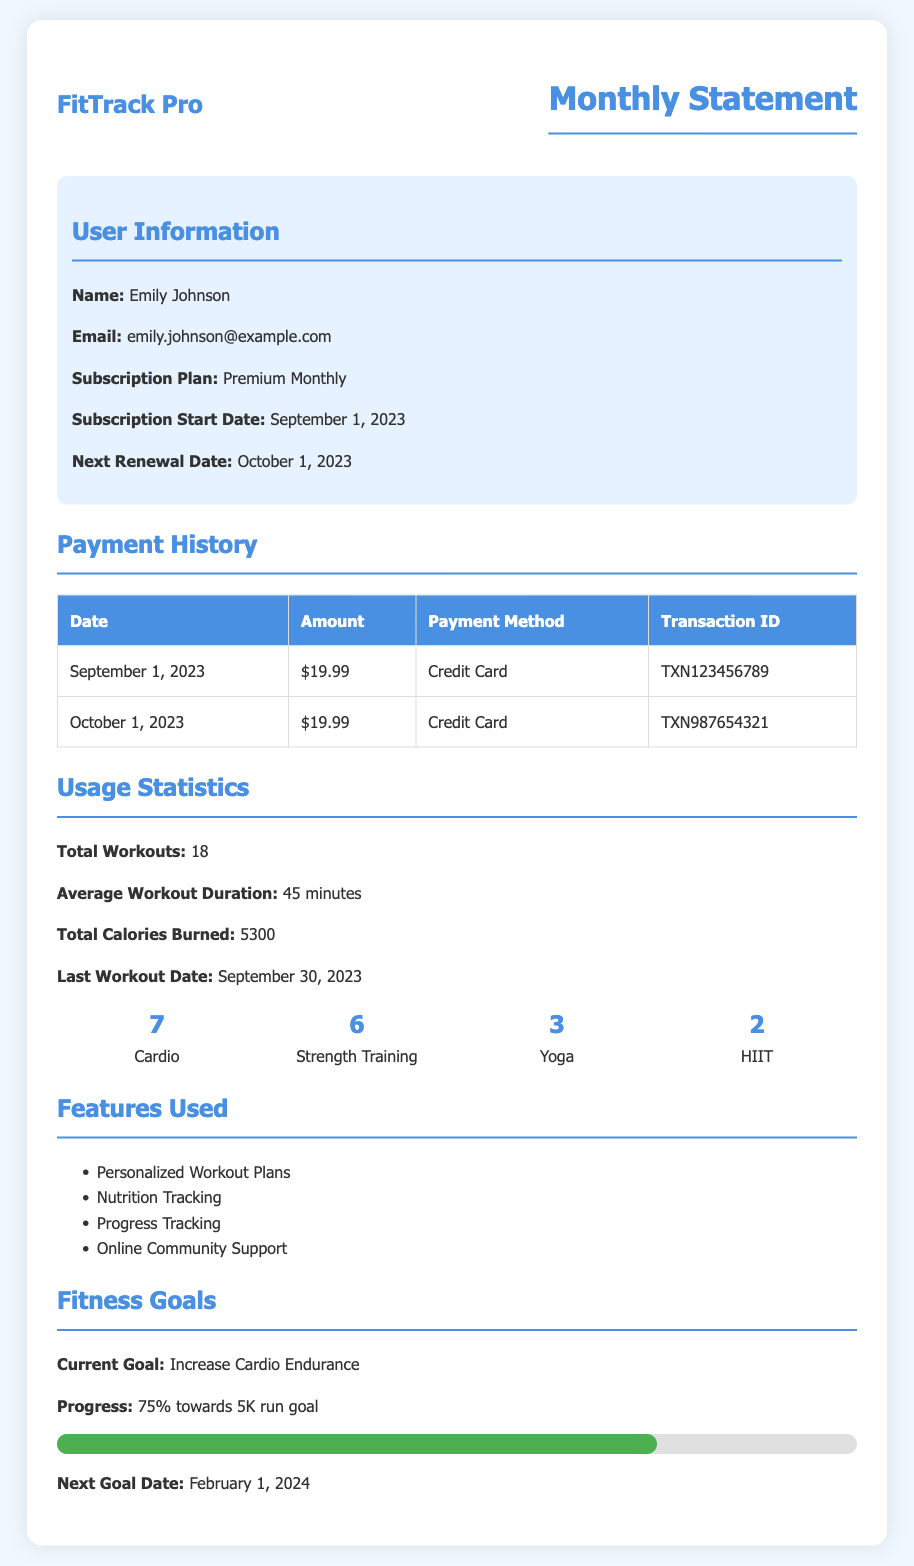What is the user's name? The user's name is provided in the User Information section of the document.
Answer: Emily Johnson What is the subscription plan? The subscription plan is specified in the User Information section of the document.
Answer: Premium Monthly What is the total number of workouts? The total number of workouts is stated in the Usage Statistics section of the document.
Answer: 18 How many calories were burned in total? The total calories burned is mentioned in the Usage Statistics section of the document.
Answer: 5300 What was the payment amount on October 1, 2023? The payment amount for that date is found in the Payment History table of the document.
Answer: $19.99 What is the next goal date? The next goal date is listed in the Features Goals section of the document.
Answer: February 1, 2024 Which workout type was done the least? This requires comparing the number of workouts across all types, found in the Usage Statistics section of the document.
Answer: HIIT How many Strength Training workouts were completed? The number of Strength Training workouts is detailed in the Usage Statistics section of the document.
Answer: 6 What was the transaction ID for the payment made on September 1, 2023? The transaction ID is provided in the Payment History table of the document.
Answer: TXN123456789 